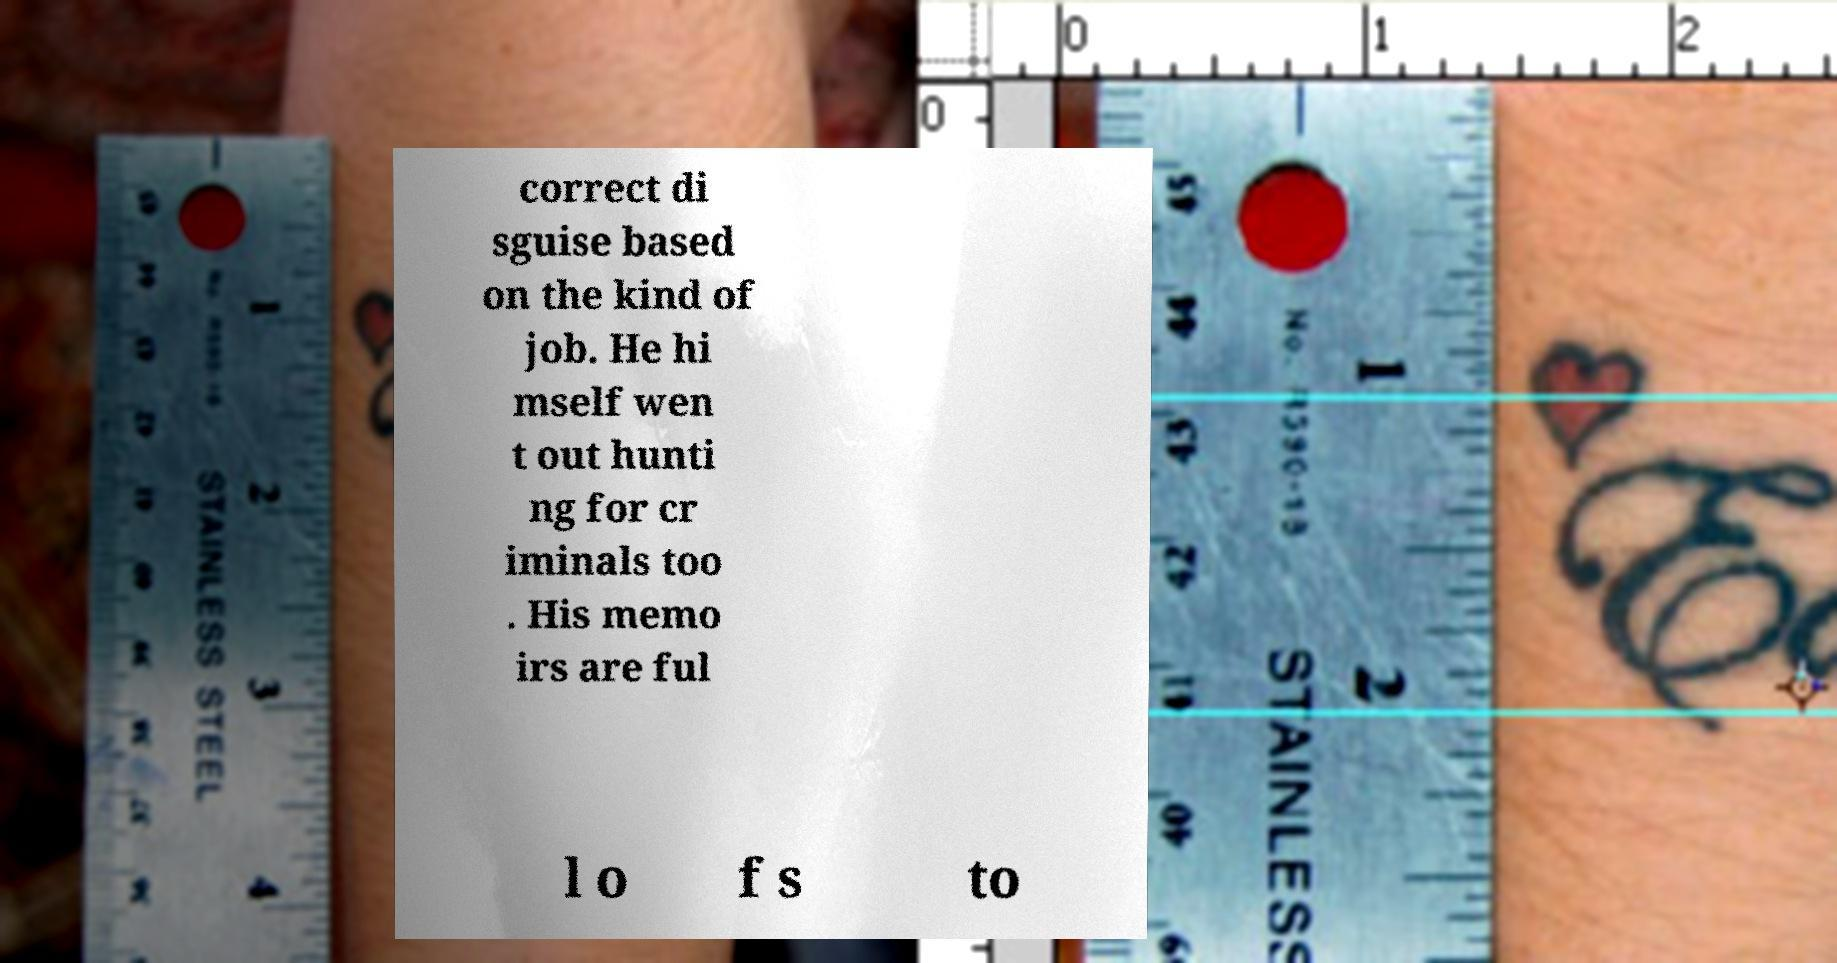Please identify and transcribe the text found in this image. correct di sguise based on the kind of job. He hi mself wen t out hunti ng for cr iminals too . His memo irs are ful l o f s to 